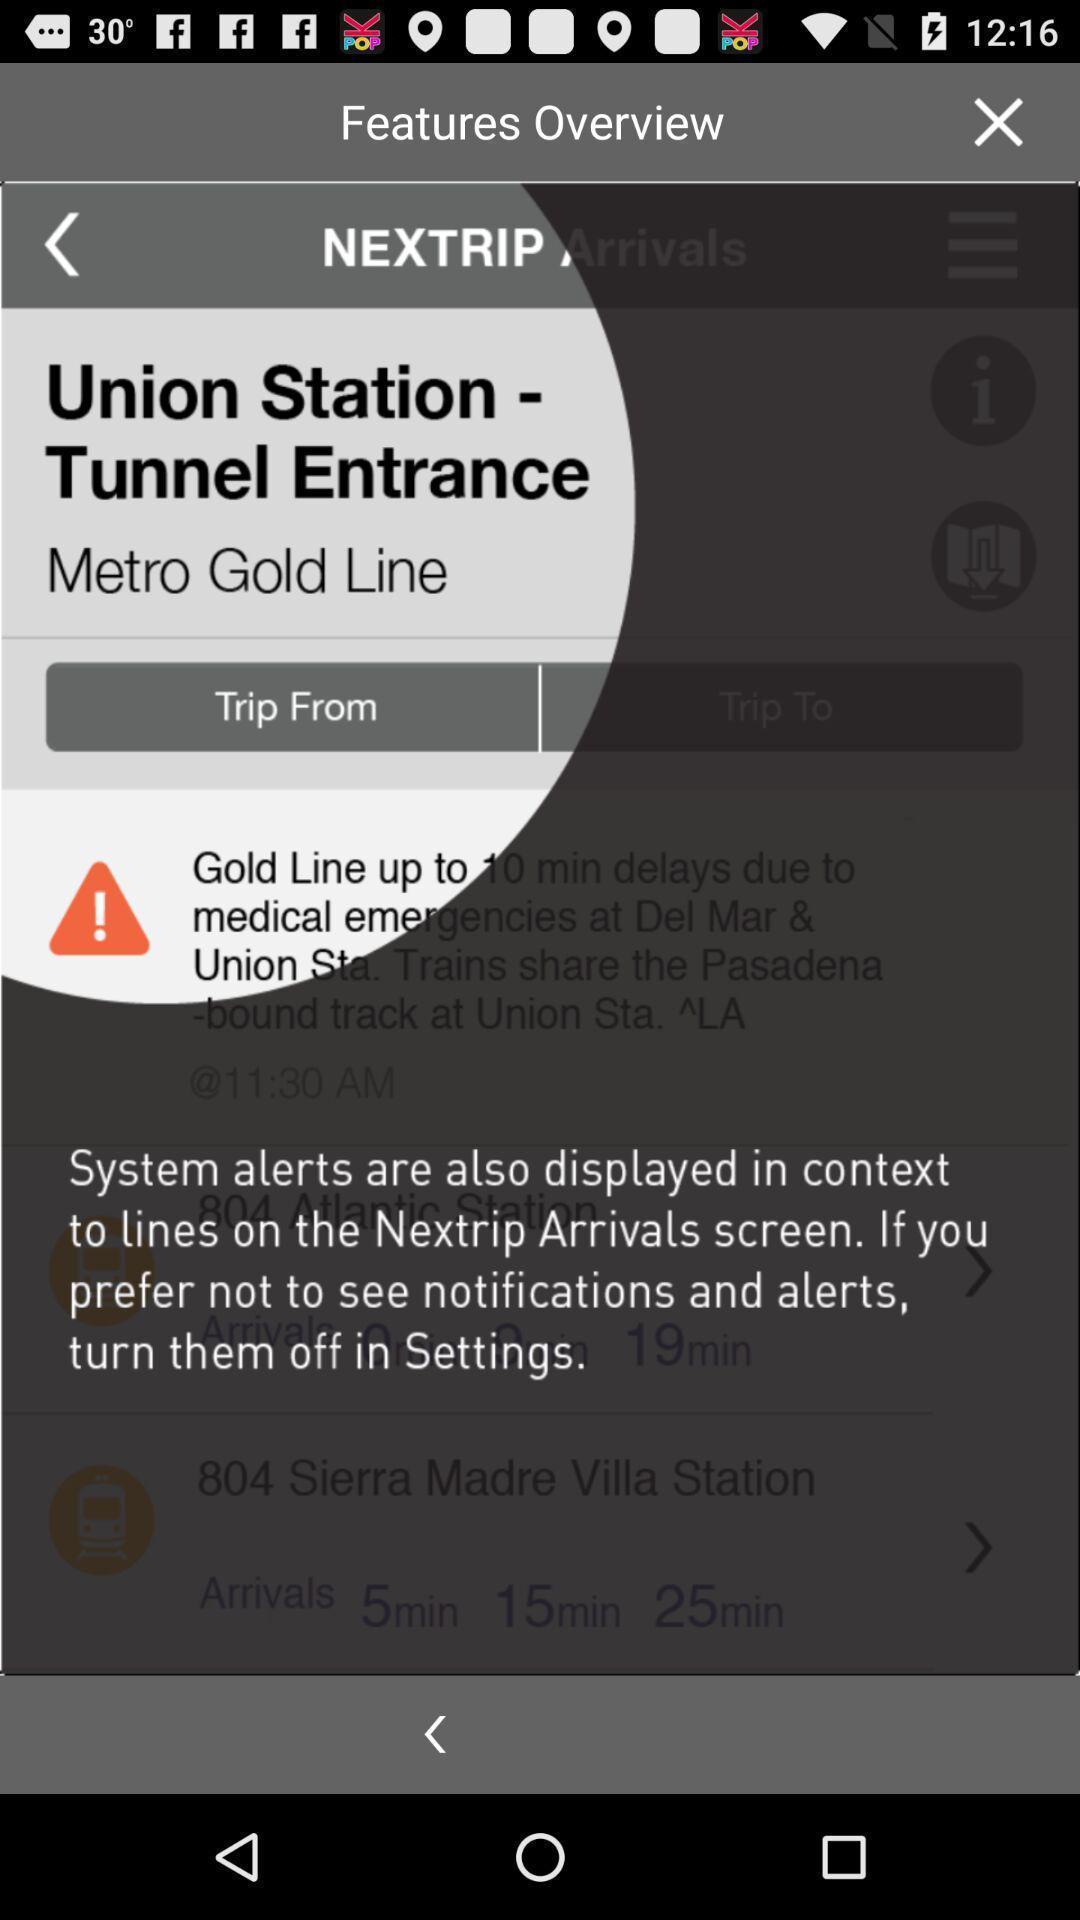Describe the key features of this screenshot. Page showing the app giving user tour. 